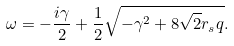Convert formula to latex. <formula><loc_0><loc_0><loc_500><loc_500>\omega = - \frac { i \gamma } { 2 } + \frac { 1 } { 2 } \sqrt { - \gamma ^ { 2 } + 8 \sqrt { 2 } r _ { s } q } .</formula> 